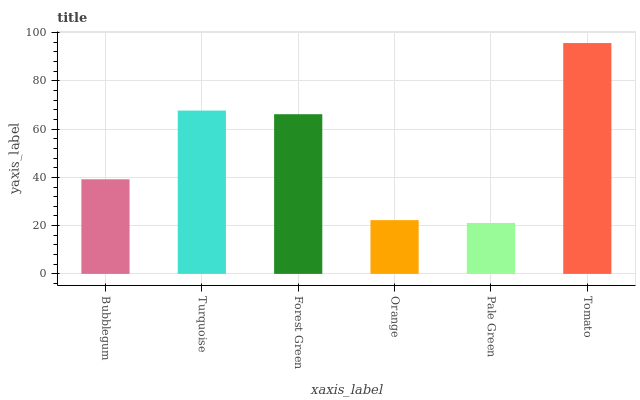Is Pale Green the minimum?
Answer yes or no. Yes. Is Tomato the maximum?
Answer yes or no. Yes. Is Turquoise the minimum?
Answer yes or no. No. Is Turquoise the maximum?
Answer yes or no. No. Is Turquoise greater than Bubblegum?
Answer yes or no. Yes. Is Bubblegum less than Turquoise?
Answer yes or no. Yes. Is Bubblegum greater than Turquoise?
Answer yes or no. No. Is Turquoise less than Bubblegum?
Answer yes or no. No. Is Forest Green the high median?
Answer yes or no. Yes. Is Bubblegum the low median?
Answer yes or no. Yes. Is Turquoise the high median?
Answer yes or no. No. Is Orange the low median?
Answer yes or no. No. 